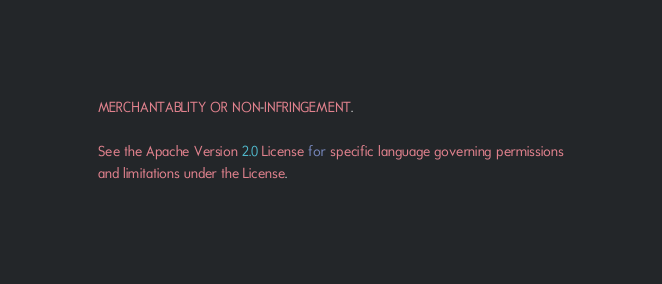<code> <loc_0><loc_0><loc_500><loc_500><_JavaScript_>MERCHANTABLITY OR NON-INFRINGEMENT.

See the Apache Version 2.0 License for specific language governing permissions
and limitations under the License.</code> 